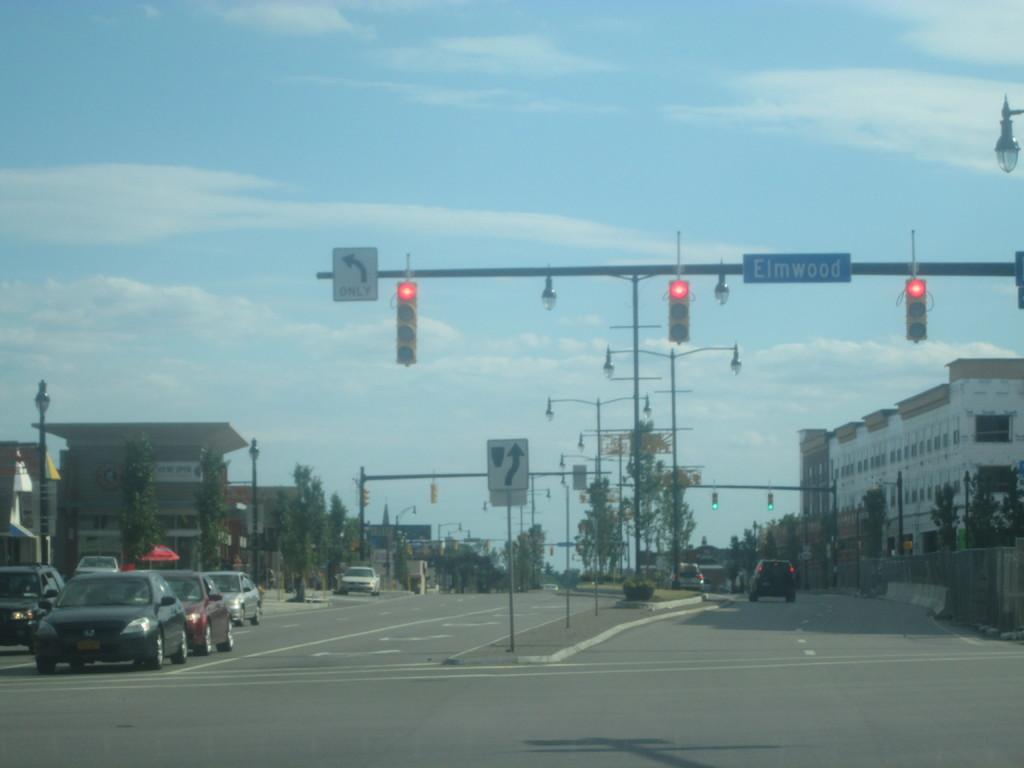Please provide a concise description of this image. In this image there is a road, on the road there are few poles, signboards, traffic signal light, vehicles visible, beside the road there are few buildings, trees, at the top there is the sky. 